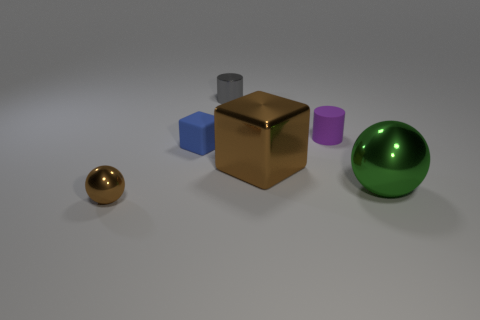There is a gray thing that is the same size as the matte block; what is it made of?
Offer a very short reply. Metal. Is the shape of the large green object the same as the tiny brown shiny object?
Your answer should be very brief. Yes. There is a tiny rubber thing that is the same shape as the large brown metal thing; what color is it?
Offer a very short reply. Blue. What number of other objects are the same material as the small gray thing?
Your response must be concise. 3. What is the shape of the small rubber thing that is right of the brown shiny thing that is to the right of the metallic ball on the left side of the large metal cube?
Keep it short and to the point. Cylinder. Are there fewer tiny things that are in front of the small rubber cube than green shiny objects that are behind the gray cylinder?
Ensure brevity in your answer.  No. Is there a large ball of the same color as the shiny cube?
Provide a succinct answer. No. Is the brown cube made of the same material as the ball on the left side of the rubber block?
Give a very brief answer. Yes. There is a small matte thing that is on the left side of the small rubber cylinder; are there any shiny objects that are on the left side of it?
Offer a very short reply. Yes. What is the color of the tiny object that is in front of the purple cylinder and to the right of the tiny brown metal thing?
Your answer should be very brief. Blue. 